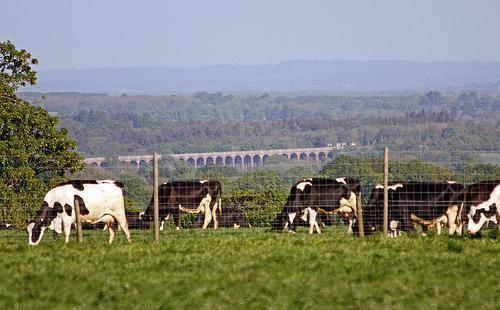How many fence posts are visible?
Give a very brief answer. 2. 